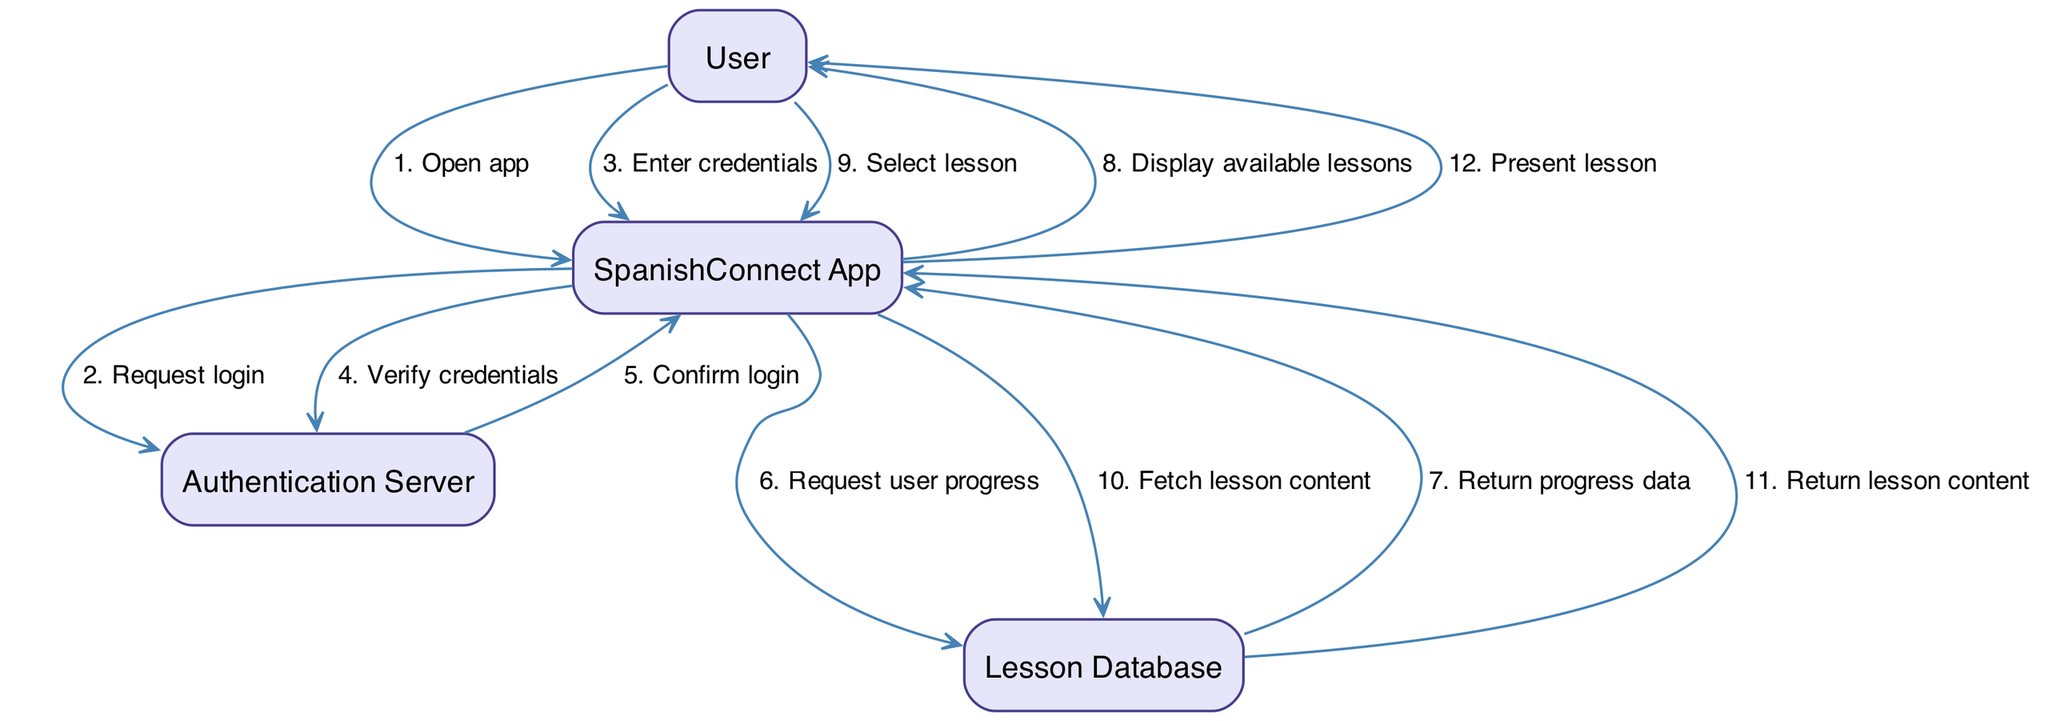What is the first action taken by the User? The first action listed in the sequence is "Open app," which is the initial interaction of the User with the SpanishConnect App.
Answer: Open app How many actors are involved in this sequence diagram? There are four actors defined in the diagram: User, SpanishConnect App, Authentication Server, and Lesson Database.
Answer: Four What does the SpanishConnect App do after verifying credentials? After verifying credentials, the next action taken by the SpanishConnect App is to "Request user progress" from the Lesson Database.
Answer: Request user progress What is the last action performed in the sequence? The last action is "Present lesson," which is the final interaction with the User after fetching the lesson content.
Answer: Present lesson Which actor confirms the login status? The Authentication Server is responsible for confirming the login status by sending a "Confirm login" message to the SpanishConnect App.
Answer: Authentication Server What action immediately follows "Display available lessons"? The User takes the action "Select lesson" immediately after the SpanishConnect App displays the available lessons.
Answer: Select lesson How many sequential actions involve the Lesson Database? There are three actions involving the Lesson Database: "Request user progress," "Fetch lesson content," and "Return lesson content."
Answer: Three What does the SpanishConnect App do before presenting the lesson? Before presenting the lesson, the SpanishConnect App "Fetch lesson content" from the Lesson Database.
Answer: Fetch lesson content Which two actors are directly involved in verifying the User's credentials? The actors involved in verifying the User's credentials are the User and the Authentication Server.
Answer: User and Authentication Server 